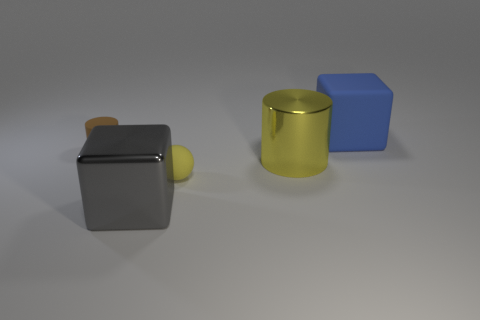Do the big metal cylinder and the ball have the same color?
Your answer should be compact. Yes. What material is the cylinder that is the same color as the matte ball?
Your answer should be compact. Metal. There is a large yellow metallic thing; does it have the same shape as the small thing that is behind the large yellow object?
Provide a short and direct response. Yes. Is there anything else that is the same color as the big rubber cube?
Provide a short and direct response. No. There is a rubber object in front of the metal cylinder; does it have the same color as the metallic object to the right of the gray metal block?
Keep it short and to the point. Yes. Are any blue matte blocks visible?
Offer a very short reply. Yes. Is there another large thing made of the same material as the large blue thing?
Give a very brief answer. No. The tiny matte cylinder is what color?
Provide a succinct answer. Brown. What is the shape of the big shiny object that is the same color as the tiny sphere?
Provide a short and direct response. Cylinder. What is the color of the rubber thing that is the same size as the matte sphere?
Offer a very short reply. Brown. 